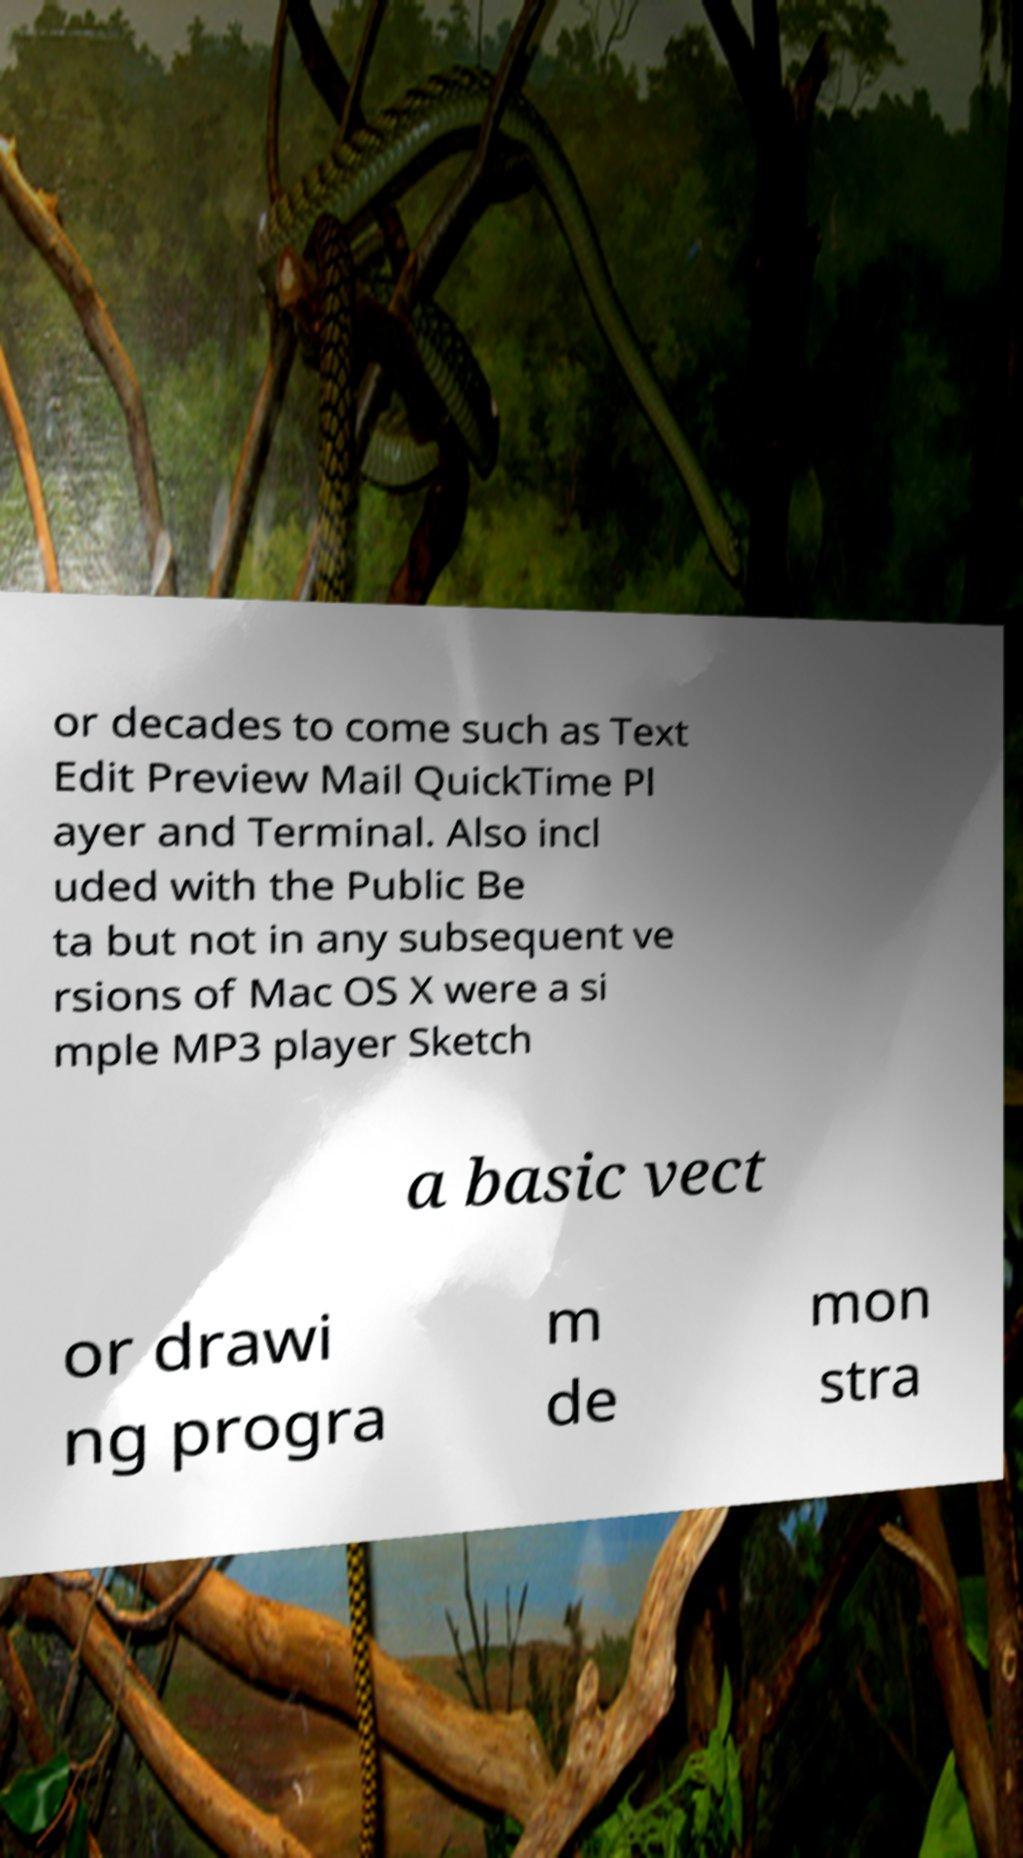Could you assist in decoding the text presented in this image and type it out clearly? or decades to come such as Text Edit Preview Mail QuickTime Pl ayer and Terminal. Also incl uded with the Public Be ta but not in any subsequent ve rsions of Mac OS X were a si mple MP3 player Sketch a basic vect or drawi ng progra m de mon stra 